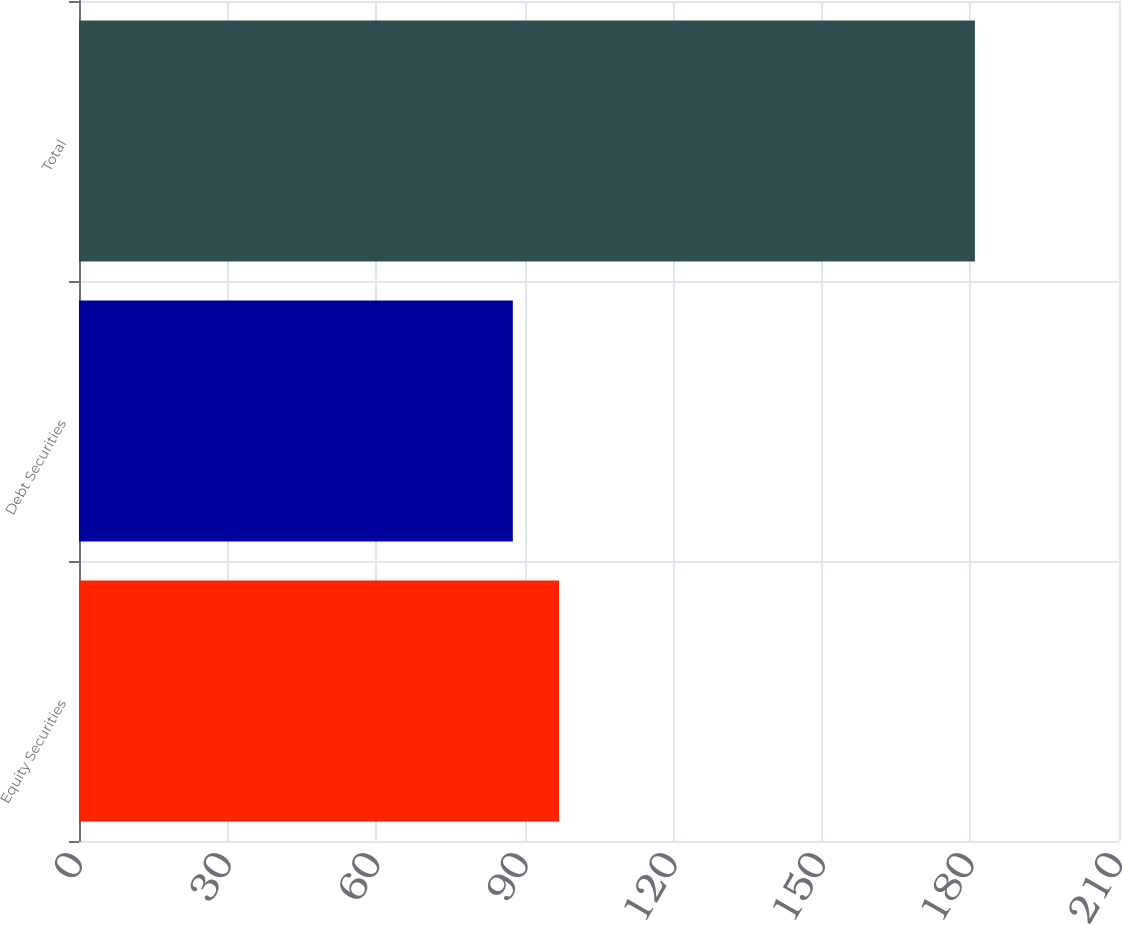Convert chart to OTSL. <chart><loc_0><loc_0><loc_500><loc_500><bar_chart><fcel>Equity Securities<fcel>Debt Securities<fcel>Total<nl><fcel>96.93<fcel>87.6<fcel>180.9<nl></chart> 